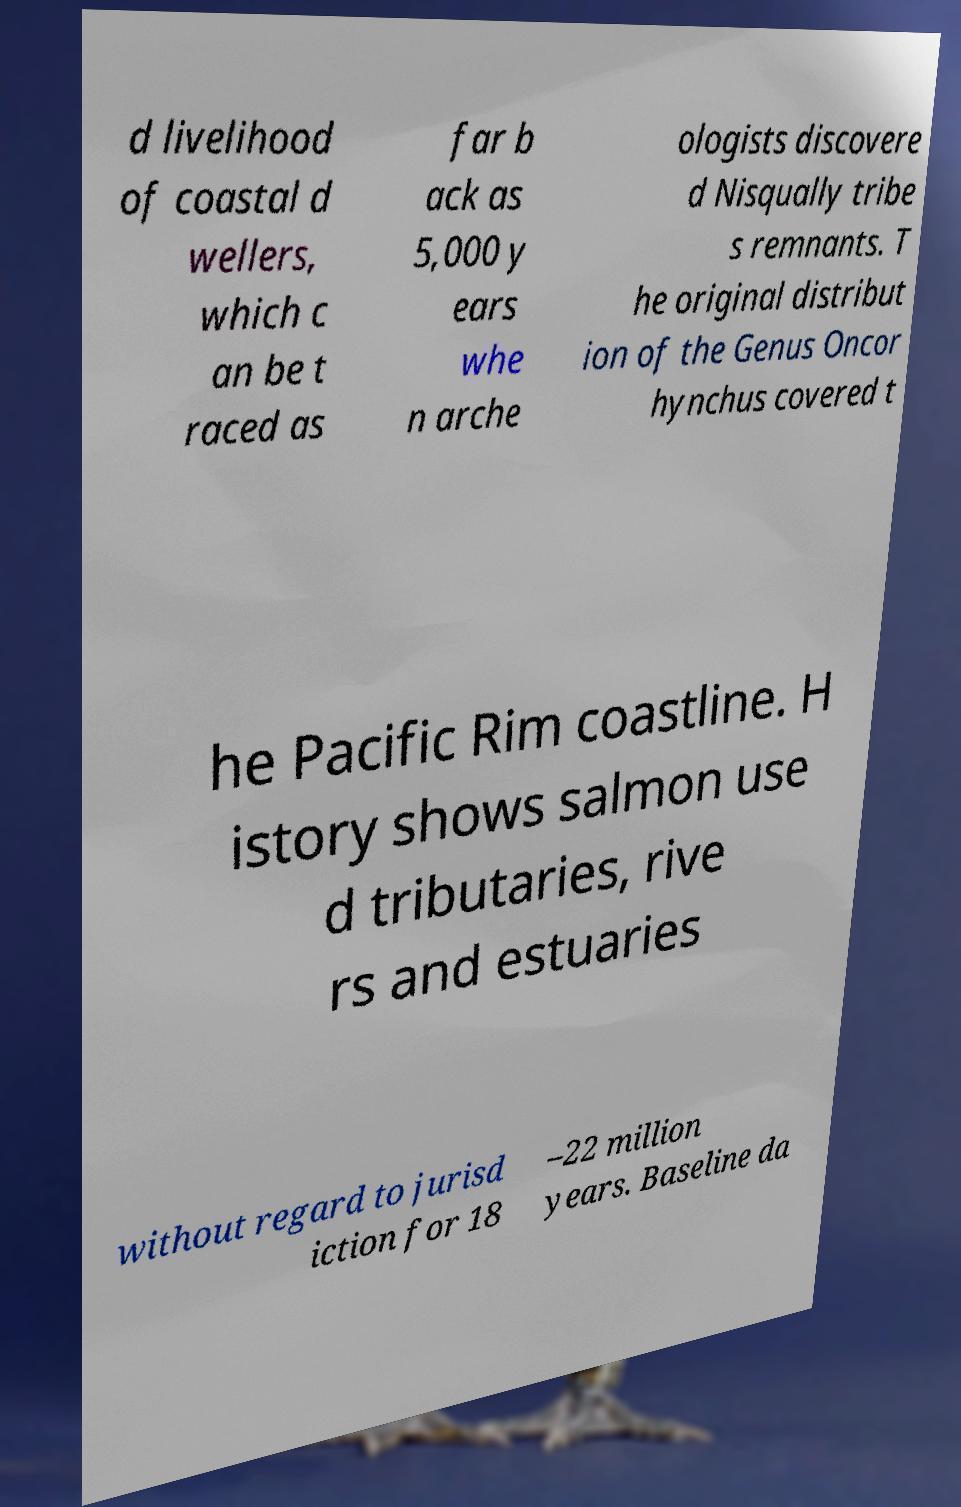What messages or text are displayed in this image? I need them in a readable, typed format. d livelihood of coastal d wellers, which c an be t raced as far b ack as 5,000 y ears whe n arche ologists discovere d Nisqually tribe s remnants. T he original distribut ion of the Genus Oncor hynchus covered t he Pacific Rim coastline. H istory shows salmon use d tributaries, rive rs and estuaries without regard to jurisd iction for 18 –22 million years. Baseline da 